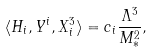<formula> <loc_0><loc_0><loc_500><loc_500>\langle H _ { i } , Y ^ { i } , X ^ { 3 } _ { i } \rangle = c _ { i } \frac { \Lambda ^ { 3 } } { M _ { * } ^ { 2 } } ,</formula> 